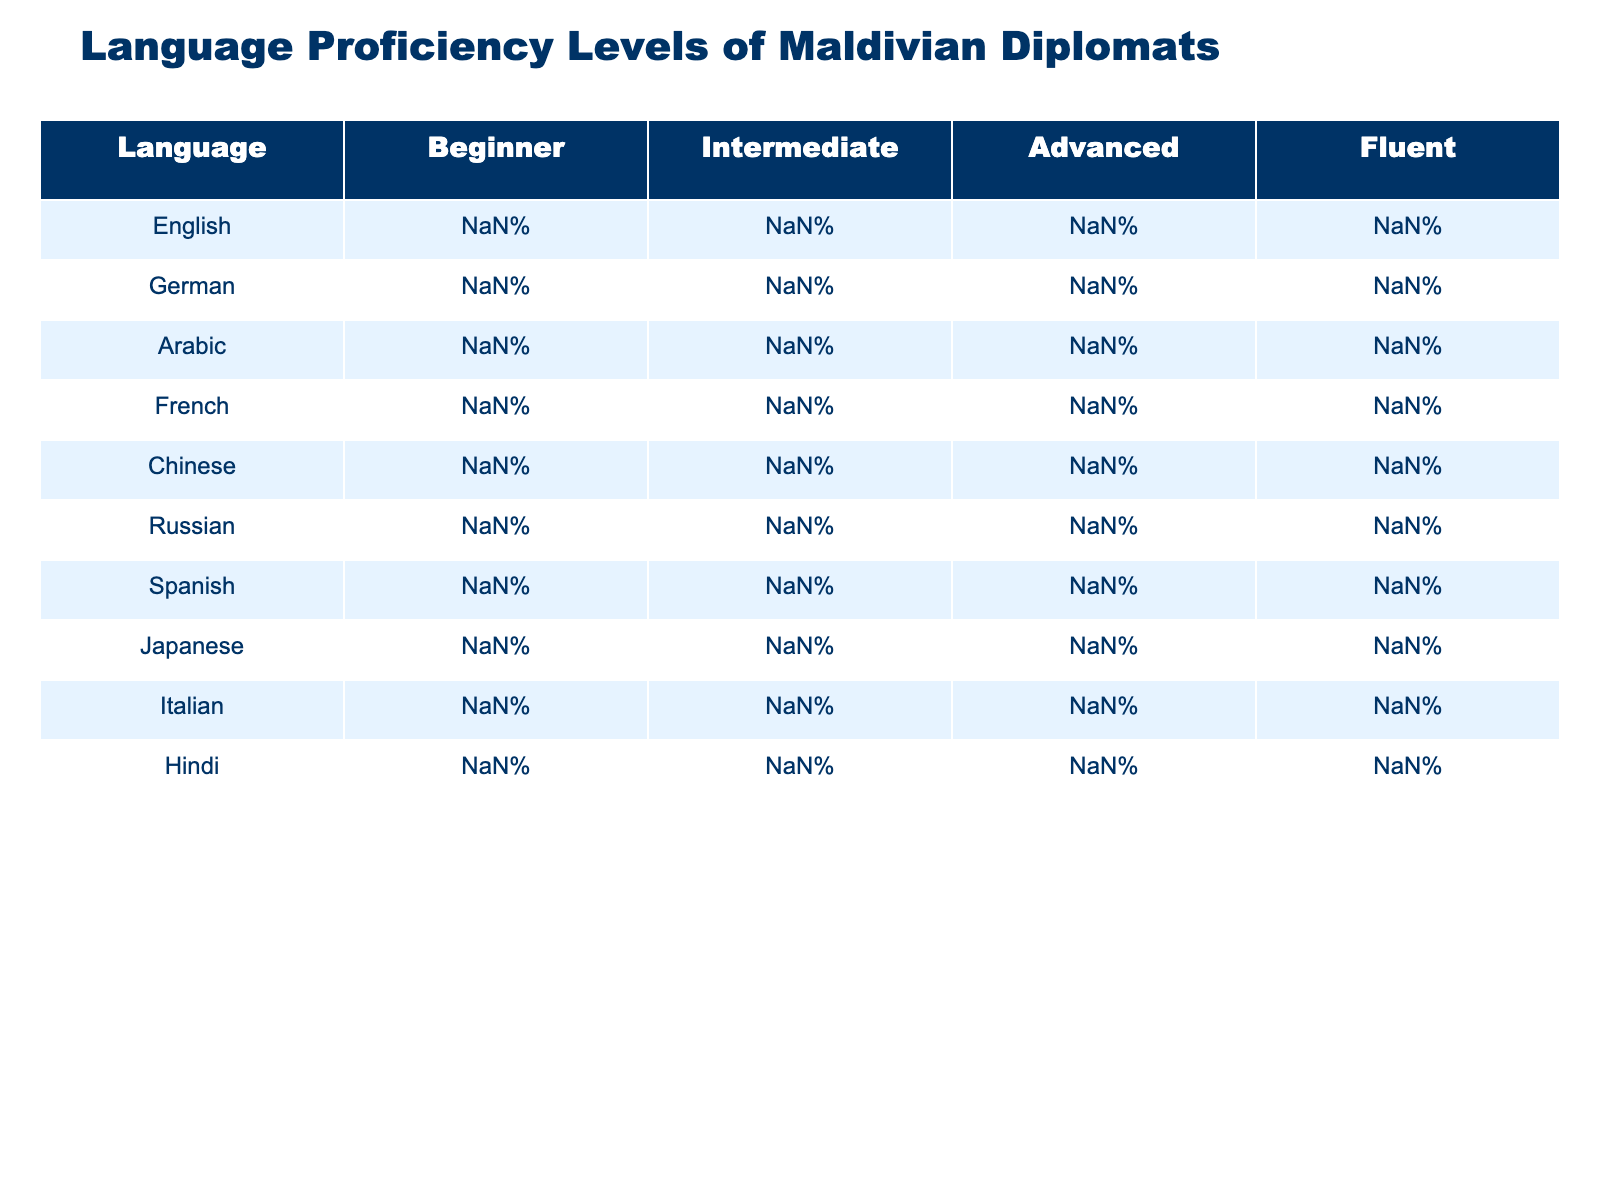What percentage of Maldivian diplomats are fluent in German? In the column for German, look at the row labeled "Fluent" which shows 10%.
Answer: 10% Which language has the highest percentage of diplomats at the beginner level? By comparing the beginner percentages across all languages, Chinese has the highest value at 60%.
Answer: Chinese What is the average percentage of diplomats proficient in Arabic at the intermediate and advanced levels combined? For Arabic, the intermediate level is 30% and advanced is 35%. Adding these gives 30 + 35 = 65%, and dividing by 2 gives an average of 32.5%.
Answer: 32.5% Is there a language where 50% or more of the diplomats are fluent? By checking the fluent percentages for all languages, none of them show a fluent percentage of 50% or higher.
Answer: No What is the total percentage of diplomats proficient in Spanish at the beginner and intermediate levels? Spanish has 45% at the beginner level and 35% at the intermediate level. Adding these together gives 45 + 35 = 80%.
Answer: 80% Which languages have more than 50% of diplomats at the beginner proficiency level? Looking at the beginner proficiency percentages, Chinese (60%), Russian (70%), and Japanese (80%) all exceed 50%.
Answer: Chinese, Russian, Japanese If we only consider advanced proficiency, which language has the lowest percentage? The advanced proficiency percentages are compared; Russian has the lowest at 8%.
Answer: Russian How many languages have a higher percentage of intermediate proficiency than beginner proficiency? By examining the table, only German, Arabic, and Spanish show higher intermediate percentages than their beginner percentages. This gives us three languages.
Answer: 3 What percentage of diplomats are fluent in French compared to those fluent in Italian? French has 10% fluent and Italian has 2%. Thus, French's fluent percentage is greater since 10% > 2%.
Answer: French Who has better overall language proficiency, those who speak German or those who speak Hindi? Analyzing the overall percentages for each language, Hindi has 30% at intermediate and 15% at advanced, totaling 45%. German has 35% at intermediate and 25% at advanced, totaling 55%. So, Germans have better proficiency.
Answer: German 